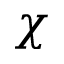Convert formula to latex. <formula><loc_0><loc_0><loc_500><loc_500>\chi</formula> 